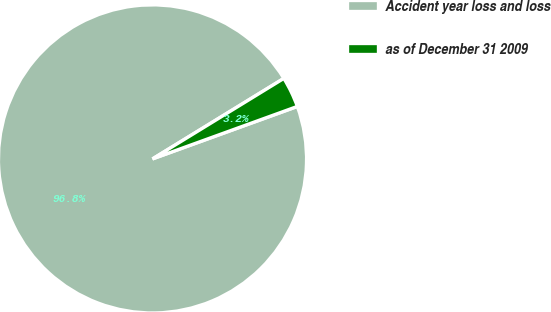Convert chart. <chart><loc_0><loc_0><loc_500><loc_500><pie_chart><fcel>Accident year loss and loss<fcel>as of December 31 2009<nl><fcel>96.78%<fcel>3.22%<nl></chart> 